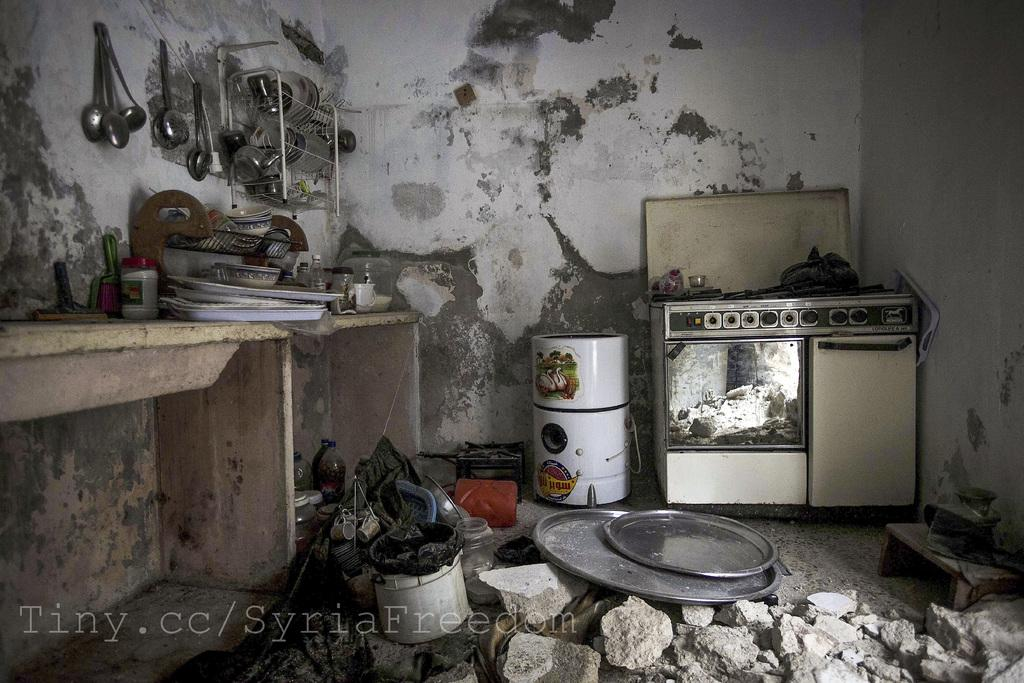What type of tools or equipment can be seen in the image? There are cooking utensils in the image. What type of appliance is present in the image? There is an oven in the image. Can you describe any other objects in the image? There are unspecified objects in the image. What color is the wall in the image? The wall of the house is painted white. What type of bean is being used to change the channel on the TV in the image? There is no TV or bean present in the image. Can you describe the twig that is being used to stir the pot in the image? There is no twig or pot present in the image. 